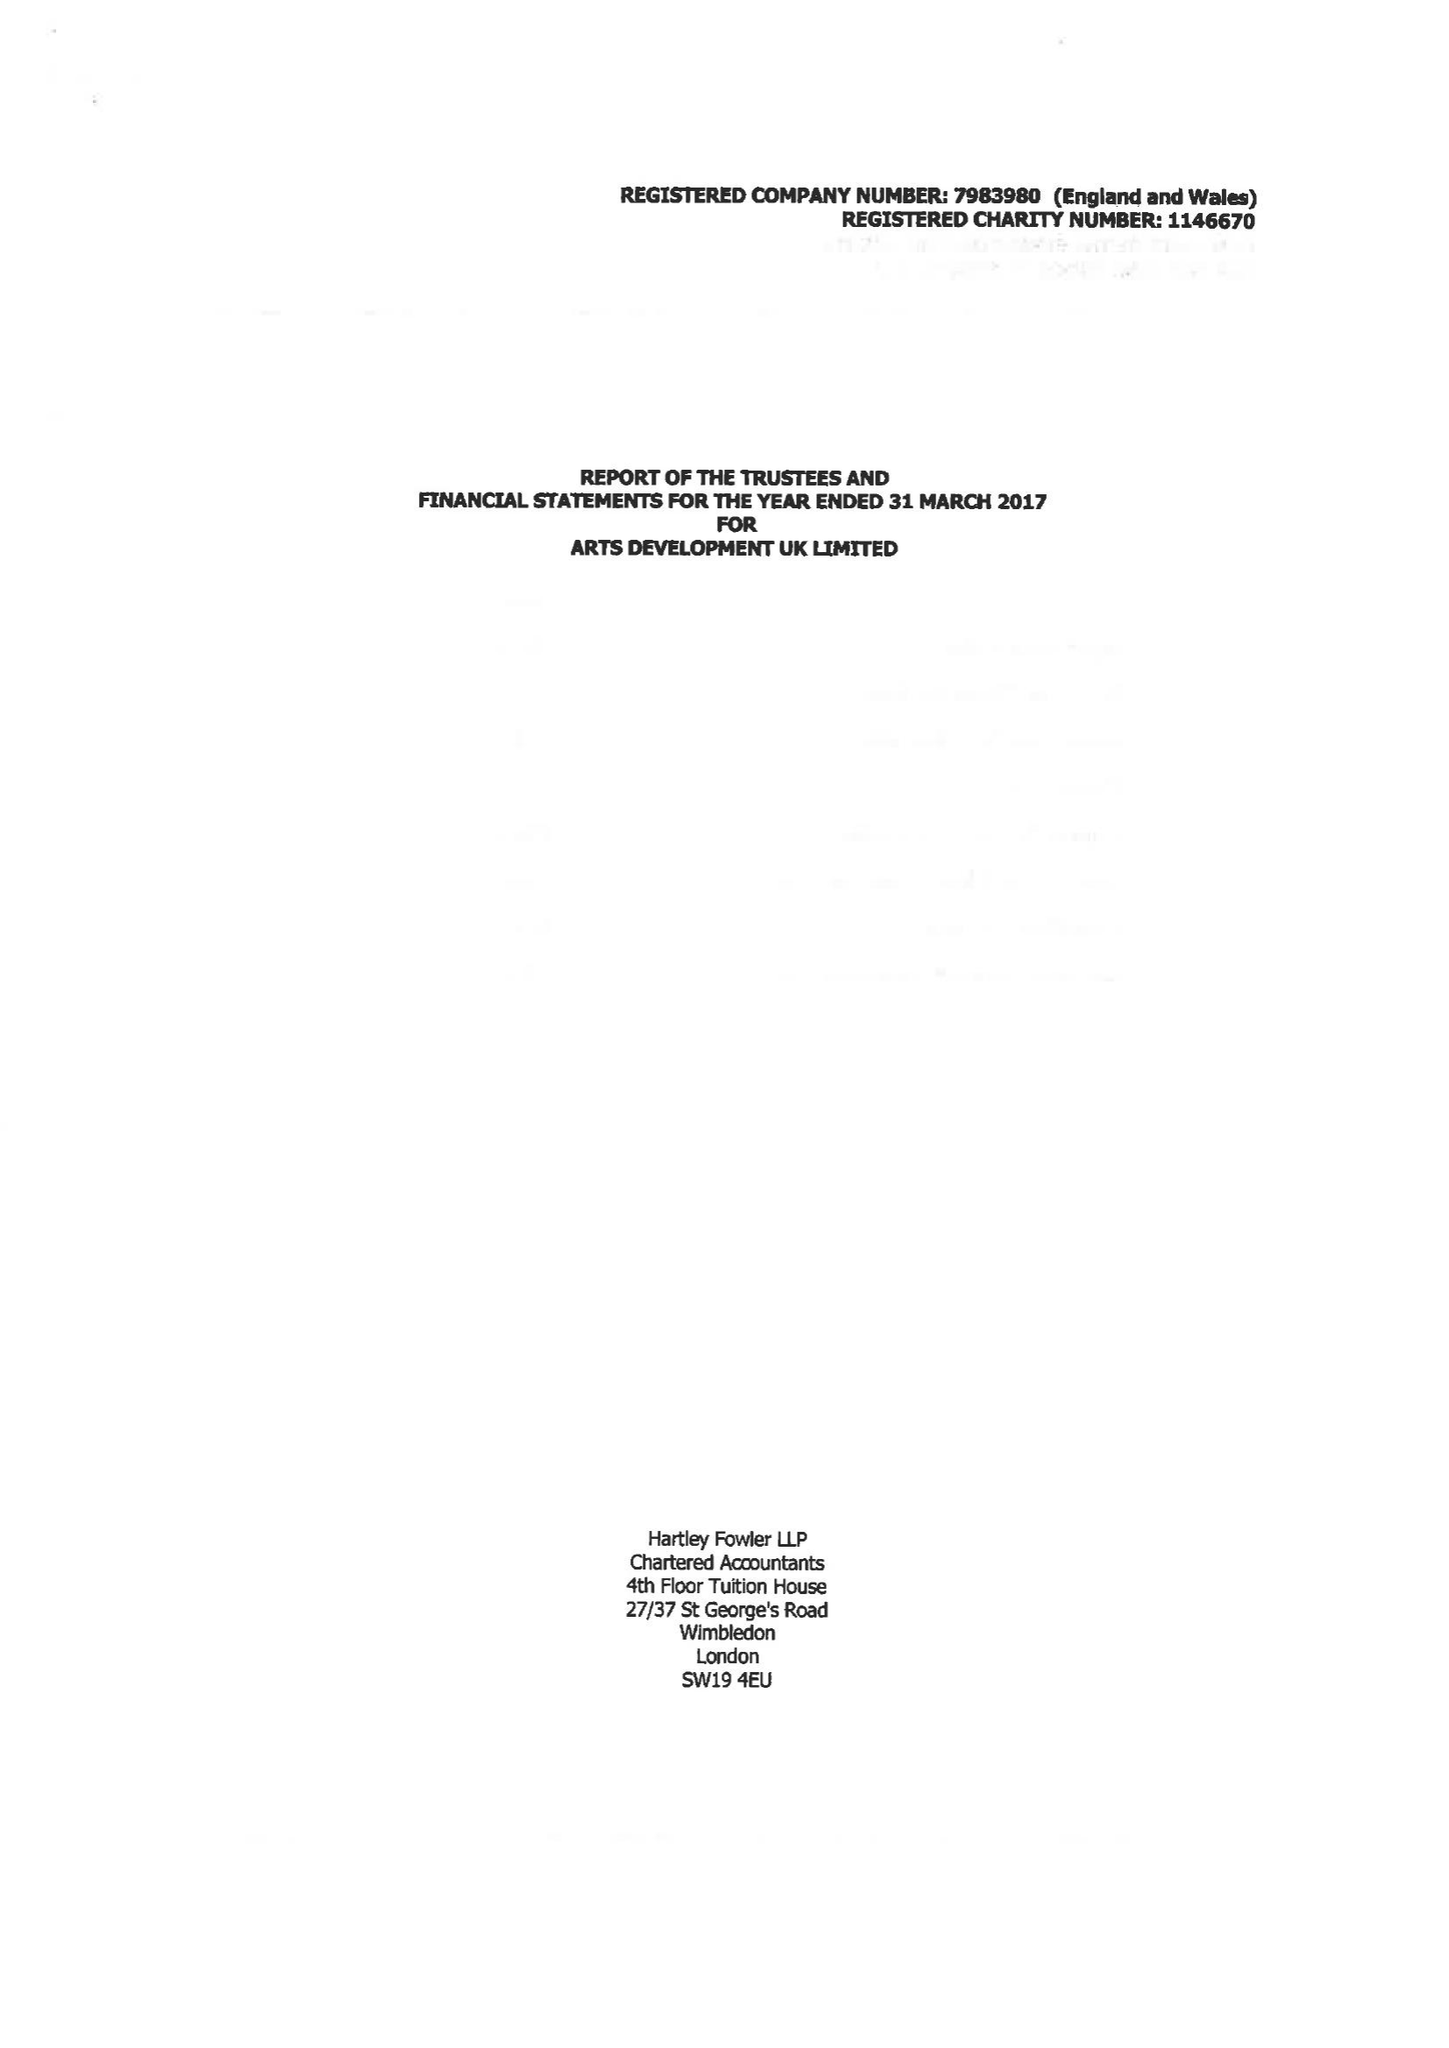What is the value for the address__postcode?
Answer the question using a single word or phrase. SA18 1SN 